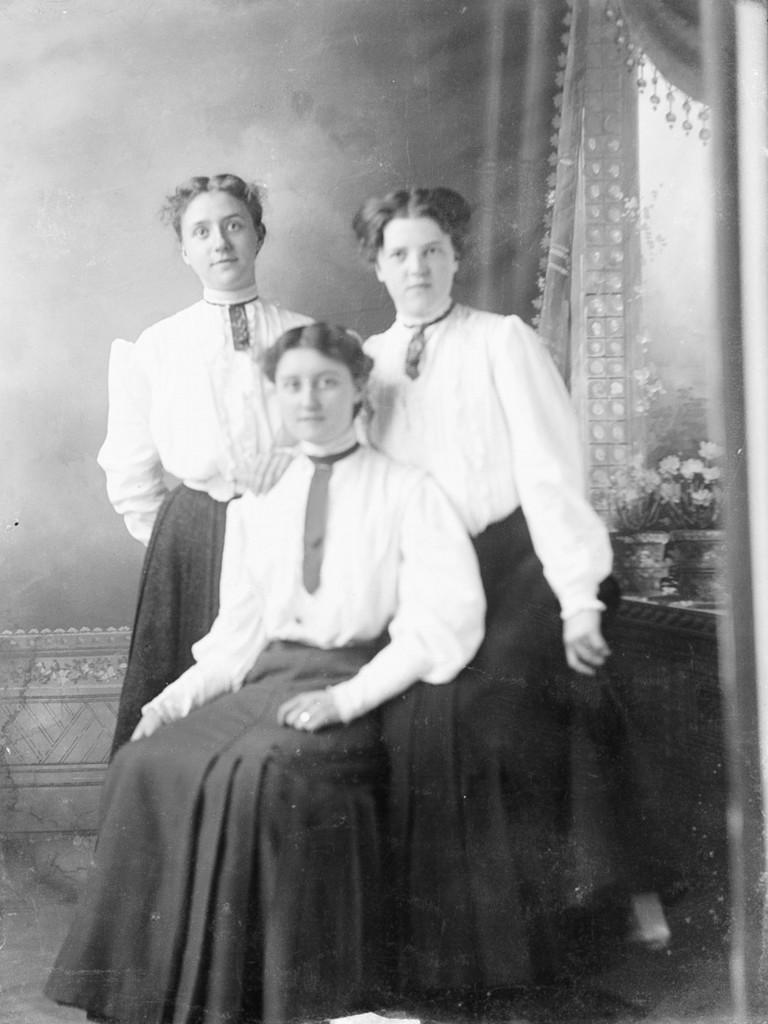How many people are in the image? There are three persons in the image. What is the position of one of the persons? One person is sitting in the front. What can be seen in the background of the image? There are flower pots and curtains visible in the background. What is the color scheme of the image? The image is black and white. What type of soap is being used by the person sitting in the front? There is no soap present in the image, as it is a black and white image of three persons and flower pots in the background. --- Facts: 1. There is a car in the image. 2. The car is red. 3. The car has four wheels. 4. There is a road in the image. 5. The road is paved. Absurd Topics: parrot, snow, dance Conversation: What is the main subject of the image? The main subject of the image is a car. What color is the car? The car is red. How many wheels does the car have? The car has four wheels. What can be seen in the background of the image? There is a road in the image. What is the condition of the road? The road is paved. Reasoning: Let's think step by step in order to produce the conversation. We start by identifying the main subject of the image, which is the car. Then, we describe the color and number of wheels of the car. Next, we mention the object visible in the background, which is a road. Finally, we address the condition of the road, which is paved. Absurd Question/Answer: Can you tell me how many parrots are sitting on the car in the image? There are no parrots present in the image; it features a red car with four wheels and a paved road in the background. --- Facts: 1. There is a person holding a book in the image. 2. The book has a blue cover. 3. The person is sitting on a chair. 4. There is a table in the image. 5. The table has a lamp on it. Absurd Topics: elephant, rain, concert Conversation: What is the person in the image holding? The person is holding a book in the image. What color is the book's cover? The book has a blue cover. What is the person sitting on? The person is sitting on a chair. What can be seen on the table in the image? There is a lamp on the table in the image. Reasoning: Let's think step by step in order to produce the conversation. We start by identifying the object the person is holding, which is a book. Then, we describe the 